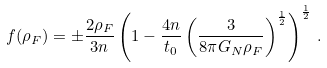<formula> <loc_0><loc_0><loc_500><loc_500>f ( \rho _ { F } ) = \pm \frac { 2 \rho _ { F } } { 3 n } \left ( 1 - \frac { 4 n } { t _ { 0 } } \left ( \frac { 3 } { 8 \pi G _ { N } \rho _ { F } } \right ) ^ { \frac { 1 } { 2 } } \right ) ^ { \frac { 1 } { 2 } } \, .</formula> 